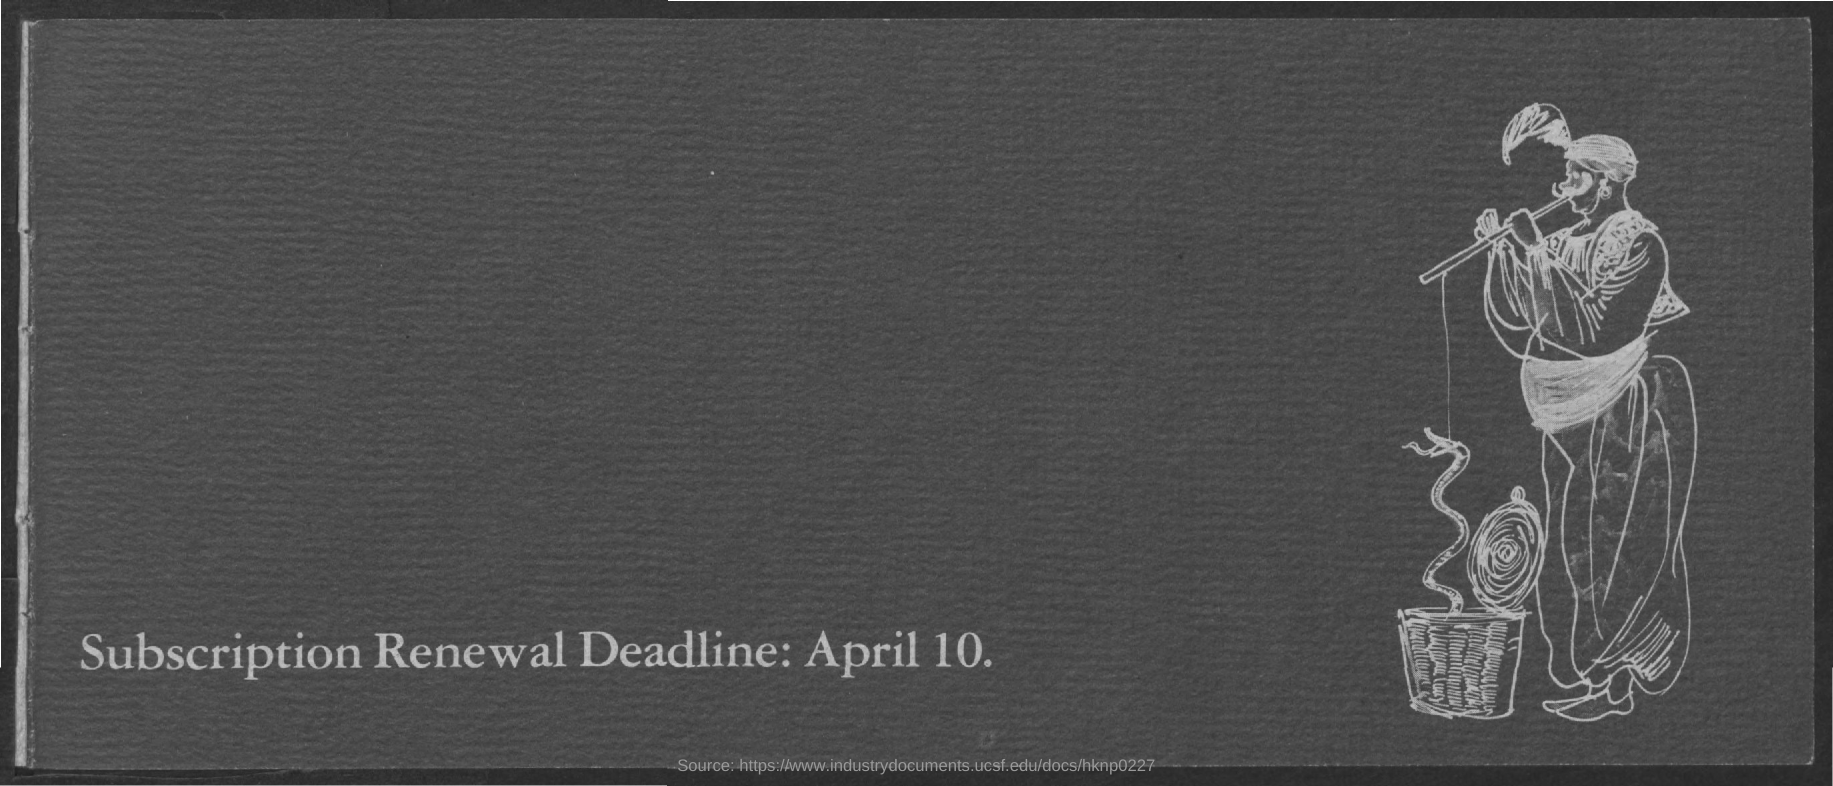Give some essential details in this illustration. It is necessary to renew subscriptions by April 10th. 